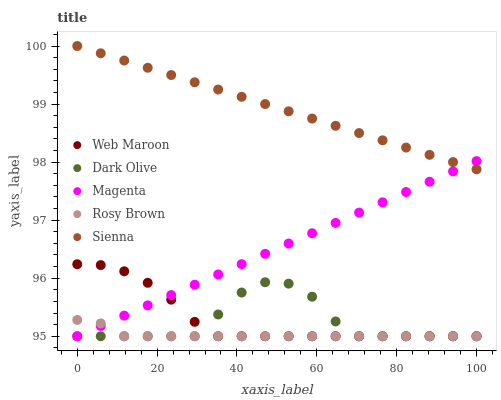Does Rosy Brown have the minimum area under the curve?
Answer yes or no. Yes. Does Sienna have the maximum area under the curve?
Answer yes or no. Yes. Does Magenta have the minimum area under the curve?
Answer yes or no. No. Does Magenta have the maximum area under the curve?
Answer yes or no. No. Is Sienna the smoothest?
Answer yes or no. Yes. Is Dark Olive the roughest?
Answer yes or no. Yes. Is Magenta the smoothest?
Answer yes or no. No. Is Magenta the roughest?
Answer yes or no. No. Does Magenta have the lowest value?
Answer yes or no. Yes. Does Sienna have the highest value?
Answer yes or no. Yes. Does Magenta have the highest value?
Answer yes or no. No. Is Rosy Brown less than Sienna?
Answer yes or no. Yes. Is Sienna greater than Dark Olive?
Answer yes or no. Yes. Does Rosy Brown intersect Dark Olive?
Answer yes or no. Yes. Is Rosy Brown less than Dark Olive?
Answer yes or no. No. Is Rosy Brown greater than Dark Olive?
Answer yes or no. No. Does Rosy Brown intersect Sienna?
Answer yes or no. No. 